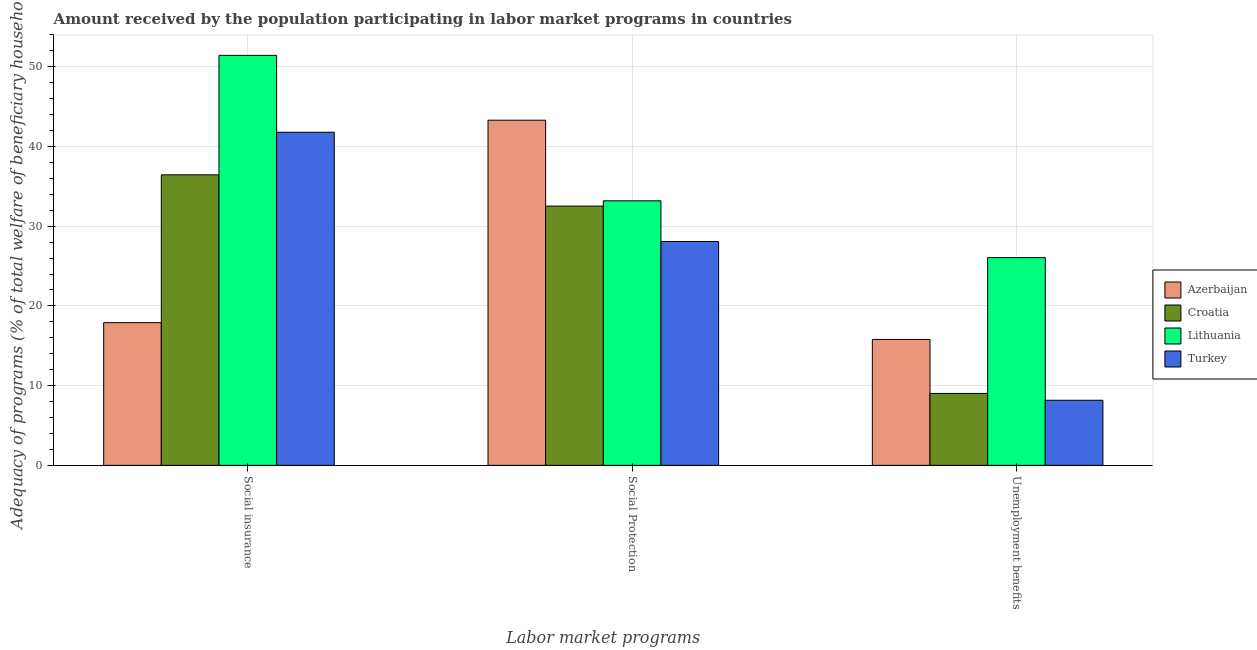How many different coloured bars are there?
Make the answer very short. 4. How many groups of bars are there?
Give a very brief answer. 3. Are the number of bars on each tick of the X-axis equal?
Offer a very short reply. Yes. What is the label of the 3rd group of bars from the left?
Give a very brief answer. Unemployment benefits. What is the amount received by the population participating in unemployment benefits programs in Croatia?
Give a very brief answer. 9.02. Across all countries, what is the maximum amount received by the population participating in unemployment benefits programs?
Your answer should be very brief. 26.06. Across all countries, what is the minimum amount received by the population participating in social insurance programs?
Offer a very short reply. 17.9. In which country was the amount received by the population participating in social insurance programs maximum?
Offer a terse response. Lithuania. What is the total amount received by the population participating in social protection programs in the graph?
Make the answer very short. 137.1. What is the difference between the amount received by the population participating in social protection programs in Lithuania and that in Turkey?
Provide a succinct answer. 5.1. What is the difference between the amount received by the population participating in social protection programs in Croatia and the amount received by the population participating in unemployment benefits programs in Azerbaijan?
Offer a terse response. 16.73. What is the average amount received by the population participating in unemployment benefits programs per country?
Your answer should be very brief. 14.76. What is the difference between the amount received by the population participating in social insurance programs and amount received by the population participating in unemployment benefits programs in Azerbaijan?
Offer a very short reply. 2.1. What is the ratio of the amount received by the population participating in social protection programs in Turkey to that in Azerbaijan?
Provide a short and direct response. 0.65. What is the difference between the highest and the second highest amount received by the population participating in unemployment benefits programs?
Keep it short and to the point. 10.26. What is the difference between the highest and the lowest amount received by the population participating in unemployment benefits programs?
Your response must be concise. 17.89. In how many countries, is the amount received by the population participating in social protection programs greater than the average amount received by the population participating in social protection programs taken over all countries?
Make the answer very short. 1. Is the sum of the amount received by the population participating in social protection programs in Azerbaijan and Turkey greater than the maximum amount received by the population participating in social insurance programs across all countries?
Give a very brief answer. Yes. What does the 2nd bar from the left in Social Protection represents?
Your answer should be very brief. Croatia. What does the 4th bar from the right in Unemployment benefits represents?
Ensure brevity in your answer.  Azerbaijan. Does the graph contain grids?
Ensure brevity in your answer.  Yes. Where does the legend appear in the graph?
Offer a very short reply. Center right. What is the title of the graph?
Offer a terse response. Amount received by the population participating in labor market programs in countries. What is the label or title of the X-axis?
Your answer should be compact. Labor market programs. What is the label or title of the Y-axis?
Your answer should be very brief. Adequacy of programs (% of total welfare of beneficiary households). What is the Adequacy of programs (% of total welfare of beneficiary households) of Azerbaijan in Social insurance?
Provide a succinct answer. 17.9. What is the Adequacy of programs (% of total welfare of beneficiary households) of Croatia in Social insurance?
Your answer should be very brief. 36.45. What is the Adequacy of programs (% of total welfare of beneficiary households) in Lithuania in Social insurance?
Provide a succinct answer. 51.43. What is the Adequacy of programs (% of total welfare of beneficiary households) of Turkey in Social insurance?
Ensure brevity in your answer.  41.79. What is the Adequacy of programs (% of total welfare of beneficiary households) in Azerbaijan in Social Protection?
Provide a short and direct response. 43.3. What is the Adequacy of programs (% of total welfare of beneficiary households) of Croatia in Social Protection?
Keep it short and to the point. 32.52. What is the Adequacy of programs (% of total welfare of beneficiary households) of Lithuania in Social Protection?
Your answer should be compact. 33.19. What is the Adequacy of programs (% of total welfare of beneficiary households) of Turkey in Social Protection?
Your answer should be very brief. 28.08. What is the Adequacy of programs (% of total welfare of beneficiary households) in Azerbaijan in Unemployment benefits?
Provide a succinct answer. 15.8. What is the Adequacy of programs (% of total welfare of beneficiary households) in Croatia in Unemployment benefits?
Give a very brief answer. 9.02. What is the Adequacy of programs (% of total welfare of beneficiary households) in Lithuania in Unemployment benefits?
Offer a terse response. 26.06. What is the Adequacy of programs (% of total welfare of beneficiary households) in Turkey in Unemployment benefits?
Keep it short and to the point. 8.17. Across all Labor market programs, what is the maximum Adequacy of programs (% of total welfare of beneficiary households) of Azerbaijan?
Your answer should be very brief. 43.3. Across all Labor market programs, what is the maximum Adequacy of programs (% of total welfare of beneficiary households) in Croatia?
Provide a succinct answer. 36.45. Across all Labor market programs, what is the maximum Adequacy of programs (% of total welfare of beneficiary households) in Lithuania?
Ensure brevity in your answer.  51.43. Across all Labor market programs, what is the maximum Adequacy of programs (% of total welfare of beneficiary households) of Turkey?
Offer a terse response. 41.79. Across all Labor market programs, what is the minimum Adequacy of programs (% of total welfare of beneficiary households) of Azerbaijan?
Keep it short and to the point. 15.8. Across all Labor market programs, what is the minimum Adequacy of programs (% of total welfare of beneficiary households) in Croatia?
Offer a terse response. 9.02. Across all Labor market programs, what is the minimum Adequacy of programs (% of total welfare of beneficiary households) of Lithuania?
Keep it short and to the point. 26.06. Across all Labor market programs, what is the minimum Adequacy of programs (% of total welfare of beneficiary households) of Turkey?
Make the answer very short. 8.17. What is the total Adequacy of programs (% of total welfare of beneficiary households) in Azerbaijan in the graph?
Keep it short and to the point. 76.99. What is the total Adequacy of programs (% of total welfare of beneficiary households) of Croatia in the graph?
Keep it short and to the point. 77.99. What is the total Adequacy of programs (% of total welfare of beneficiary households) in Lithuania in the graph?
Your answer should be compact. 110.68. What is the total Adequacy of programs (% of total welfare of beneficiary households) in Turkey in the graph?
Ensure brevity in your answer.  78.04. What is the difference between the Adequacy of programs (% of total welfare of beneficiary households) in Azerbaijan in Social insurance and that in Social Protection?
Your answer should be very brief. -25.4. What is the difference between the Adequacy of programs (% of total welfare of beneficiary households) in Croatia in Social insurance and that in Social Protection?
Ensure brevity in your answer.  3.92. What is the difference between the Adequacy of programs (% of total welfare of beneficiary households) in Lithuania in Social insurance and that in Social Protection?
Your response must be concise. 18.24. What is the difference between the Adequacy of programs (% of total welfare of beneficiary households) of Turkey in Social insurance and that in Social Protection?
Provide a succinct answer. 13.71. What is the difference between the Adequacy of programs (% of total welfare of beneficiary households) in Azerbaijan in Social insurance and that in Unemployment benefits?
Make the answer very short. 2.1. What is the difference between the Adequacy of programs (% of total welfare of beneficiary households) in Croatia in Social insurance and that in Unemployment benefits?
Your answer should be very brief. 27.43. What is the difference between the Adequacy of programs (% of total welfare of beneficiary households) of Lithuania in Social insurance and that in Unemployment benefits?
Your response must be concise. 25.37. What is the difference between the Adequacy of programs (% of total welfare of beneficiary households) in Turkey in Social insurance and that in Unemployment benefits?
Keep it short and to the point. 33.62. What is the difference between the Adequacy of programs (% of total welfare of beneficiary households) of Azerbaijan in Social Protection and that in Unemployment benefits?
Offer a very short reply. 27.5. What is the difference between the Adequacy of programs (% of total welfare of beneficiary households) of Croatia in Social Protection and that in Unemployment benefits?
Provide a succinct answer. 23.5. What is the difference between the Adequacy of programs (% of total welfare of beneficiary households) of Lithuania in Social Protection and that in Unemployment benefits?
Keep it short and to the point. 7.13. What is the difference between the Adequacy of programs (% of total welfare of beneficiary households) of Turkey in Social Protection and that in Unemployment benefits?
Offer a very short reply. 19.92. What is the difference between the Adequacy of programs (% of total welfare of beneficiary households) in Azerbaijan in Social insurance and the Adequacy of programs (% of total welfare of beneficiary households) in Croatia in Social Protection?
Provide a succinct answer. -14.62. What is the difference between the Adequacy of programs (% of total welfare of beneficiary households) in Azerbaijan in Social insurance and the Adequacy of programs (% of total welfare of beneficiary households) in Lithuania in Social Protection?
Provide a short and direct response. -15.29. What is the difference between the Adequacy of programs (% of total welfare of beneficiary households) in Azerbaijan in Social insurance and the Adequacy of programs (% of total welfare of beneficiary households) in Turkey in Social Protection?
Offer a very short reply. -10.18. What is the difference between the Adequacy of programs (% of total welfare of beneficiary households) in Croatia in Social insurance and the Adequacy of programs (% of total welfare of beneficiary households) in Lithuania in Social Protection?
Keep it short and to the point. 3.26. What is the difference between the Adequacy of programs (% of total welfare of beneficiary households) of Croatia in Social insurance and the Adequacy of programs (% of total welfare of beneficiary households) of Turkey in Social Protection?
Keep it short and to the point. 8.36. What is the difference between the Adequacy of programs (% of total welfare of beneficiary households) of Lithuania in Social insurance and the Adequacy of programs (% of total welfare of beneficiary households) of Turkey in Social Protection?
Give a very brief answer. 23.35. What is the difference between the Adequacy of programs (% of total welfare of beneficiary households) of Azerbaijan in Social insurance and the Adequacy of programs (% of total welfare of beneficiary households) of Croatia in Unemployment benefits?
Provide a succinct answer. 8.88. What is the difference between the Adequacy of programs (% of total welfare of beneficiary households) of Azerbaijan in Social insurance and the Adequacy of programs (% of total welfare of beneficiary households) of Lithuania in Unemployment benefits?
Offer a terse response. -8.16. What is the difference between the Adequacy of programs (% of total welfare of beneficiary households) of Azerbaijan in Social insurance and the Adequacy of programs (% of total welfare of beneficiary households) of Turkey in Unemployment benefits?
Your answer should be compact. 9.73. What is the difference between the Adequacy of programs (% of total welfare of beneficiary households) of Croatia in Social insurance and the Adequacy of programs (% of total welfare of beneficiary households) of Lithuania in Unemployment benefits?
Give a very brief answer. 10.39. What is the difference between the Adequacy of programs (% of total welfare of beneficiary households) of Croatia in Social insurance and the Adequacy of programs (% of total welfare of beneficiary households) of Turkey in Unemployment benefits?
Offer a terse response. 28.28. What is the difference between the Adequacy of programs (% of total welfare of beneficiary households) in Lithuania in Social insurance and the Adequacy of programs (% of total welfare of beneficiary households) in Turkey in Unemployment benefits?
Your response must be concise. 43.26. What is the difference between the Adequacy of programs (% of total welfare of beneficiary households) of Azerbaijan in Social Protection and the Adequacy of programs (% of total welfare of beneficiary households) of Croatia in Unemployment benefits?
Your answer should be very brief. 34.28. What is the difference between the Adequacy of programs (% of total welfare of beneficiary households) of Azerbaijan in Social Protection and the Adequacy of programs (% of total welfare of beneficiary households) of Lithuania in Unemployment benefits?
Your answer should be compact. 17.24. What is the difference between the Adequacy of programs (% of total welfare of beneficiary households) in Azerbaijan in Social Protection and the Adequacy of programs (% of total welfare of beneficiary households) in Turkey in Unemployment benefits?
Ensure brevity in your answer.  35.13. What is the difference between the Adequacy of programs (% of total welfare of beneficiary households) in Croatia in Social Protection and the Adequacy of programs (% of total welfare of beneficiary households) in Lithuania in Unemployment benefits?
Keep it short and to the point. 6.47. What is the difference between the Adequacy of programs (% of total welfare of beneficiary households) in Croatia in Social Protection and the Adequacy of programs (% of total welfare of beneficiary households) in Turkey in Unemployment benefits?
Make the answer very short. 24.36. What is the difference between the Adequacy of programs (% of total welfare of beneficiary households) in Lithuania in Social Protection and the Adequacy of programs (% of total welfare of beneficiary households) in Turkey in Unemployment benefits?
Your response must be concise. 25.02. What is the average Adequacy of programs (% of total welfare of beneficiary households) of Azerbaijan per Labor market programs?
Make the answer very short. 25.66. What is the average Adequacy of programs (% of total welfare of beneficiary households) of Croatia per Labor market programs?
Ensure brevity in your answer.  26. What is the average Adequacy of programs (% of total welfare of beneficiary households) in Lithuania per Labor market programs?
Your response must be concise. 36.89. What is the average Adequacy of programs (% of total welfare of beneficiary households) in Turkey per Labor market programs?
Make the answer very short. 26.01. What is the difference between the Adequacy of programs (% of total welfare of beneficiary households) in Azerbaijan and Adequacy of programs (% of total welfare of beneficiary households) in Croatia in Social insurance?
Ensure brevity in your answer.  -18.55. What is the difference between the Adequacy of programs (% of total welfare of beneficiary households) in Azerbaijan and Adequacy of programs (% of total welfare of beneficiary households) in Lithuania in Social insurance?
Make the answer very short. -33.53. What is the difference between the Adequacy of programs (% of total welfare of beneficiary households) of Azerbaijan and Adequacy of programs (% of total welfare of beneficiary households) of Turkey in Social insurance?
Give a very brief answer. -23.89. What is the difference between the Adequacy of programs (% of total welfare of beneficiary households) in Croatia and Adequacy of programs (% of total welfare of beneficiary households) in Lithuania in Social insurance?
Your response must be concise. -14.98. What is the difference between the Adequacy of programs (% of total welfare of beneficiary households) of Croatia and Adequacy of programs (% of total welfare of beneficiary households) of Turkey in Social insurance?
Offer a terse response. -5.34. What is the difference between the Adequacy of programs (% of total welfare of beneficiary households) in Lithuania and Adequacy of programs (% of total welfare of beneficiary households) in Turkey in Social insurance?
Ensure brevity in your answer.  9.64. What is the difference between the Adequacy of programs (% of total welfare of beneficiary households) of Azerbaijan and Adequacy of programs (% of total welfare of beneficiary households) of Croatia in Social Protection?
Offer a very short reply. 10.78. What is the difference between the Adequacy of programs (% of total welfare of beneficiary households) of Azerbaijan and Adequacy of programs (% of total welfare of beneficiary households) of Lithuania in Social Protection?
Keep it short and to the point. 10.11. What is the difference between the Adequacy of programs (% of total welfare of beneficiary households) of Azerbaijan and Adequacy of programs (% of total welfare of beneficiary households) of Turkey in Social Protection?
Make the answer very short. 15.22. What is the difference between the Adequacy of programs (% of total welfare of beneficiary households) of Croatia and Adequacy of programs (% of total welfare of beneficiary households) of Lithuania in Social Protection?
Provide a succinct answer. -0.66. What is the difference between the Adequacy of programs (% of total welfare of beneficiary households) in Croatia and Adequacy of programs (% of total welfare of beneficiary households) in Turkey in Social Protection?
Provide a succinct answer. 4.44. What is the difference between the Adequacy of programs (% of total welfare of beneficiary households) of Lithuania and Adequacy of programs (% of total welfare of beneficiary households) of Turkey in Social Protection?
Keep it short and to the point. 5.1. What is the difference between the Adequacy of programs (% of total welfare of beneficiary households) in Azerbaijan and Adequacy of programs (% of total welfare of beneficiary households) in Croatia in Unemployment benefits?
Provide a succinct answer. 6.77. What is the difference between the Adequacy of programs (% of total welfare of beneficiary households) of Azerbaijan and Adequacy of programs (% of total welfare of beneficiary households) of Lithuania in Unemployment benefits?
Your answer should be compact. -10.26. What is the difference between the Adequacy of programs (% of total welfare of beneficiary households) in Azerbaijan and Adequacy of programs (% of total welfare of beneficiary households) in Turkey in Unemployment benefits?
Make the answer very short. 7.63. What is the difference between the Adequacy of programs (% of total welfare of beneficiary households) in Croatia and Adequacy of programs (% of total welfare of beneficiary households) in Lithuania in Unemployment benefits?
Keep it short and to the point. -17.04. What is the difference between the Adequacy of programs (% of total welfare of beneficiary households) in Croatia and Adequacy of programs (% of total welfare of beneficiary households) in Turkey in Unemployment benefits?
Your response must be concise. 0.85. What is the difference between the Adequacy of programs (% of total welfare of beneficiary households) in Lithuania and Adequacy of programs (% of total welfare of beneficiary households) in Turkey in Unemployment benefits?
Provide a short and direct response. 17.89. What is the ratio of the Adequacy of programs (% of total welfare of beneficiary households) of Azerbaijan in Social insurance to that in Social Protection?
Give a very brief answer. 0.41. What is the ratio of the Adequacy of programs (% of total welfare of beneficiary households) of Croatia in Social insurance to that in Social Protection?
Keep it short and to the point. 1.12. What is the ratio of the Adequacy of programs (% of total welfare of beneficiary households) in Lithuania in Social insurance to that in Social Protection?
Give a very brief answer. 1.55. What is the ratio of the Adequacy of programs (% of total welfare of beneficiary households) of Turkey in Social insurance to that in Social Protection?
Your answer should be very brief. 1.49. What is the ratio of the Adequacy of programs (% of total welfare of beneficiary households) in Azerbaijan in Social insurance to that in Unemployment benefits?
Keep it short and to the point. 1.13. What is the ratio of the Adequacy of programs (% of total welfare of beneficiary households) of Croatia in Social insurance to that in Unemployment benefits?
Offer a terse response. 4.04. What is the ratio of the Adequacy of programs (% of total welfare of beneficiary households) in Lithuania in Social insurance to that in Unemployment benefits?
Your answer should be compact. 1.97. What is the ratio of the Adequacy of programs (% of total welfare of beneficiary households) of Turkey in Social insurance to that in Unemployment benefits?
Make the answer very short. 5.12. What is the ratio of the Adequacy of programs (% of total welfare of beneficiary households) of Azerbaijan in Social Protection to that in Unemployment benefits?
Offer a terse response. 2.74. What is the ratio of the Adequacy of programs (% of total welfare of beneficiary households) of Croatia in Social Protection to that in Unemployment benefits?
Provide a succinct answer. 3.61. What is the ratio of the Adequacy of programs (% of total welfare of beneficiary households) of Lithuania in Social Protection to that in Unemployment benefits?
Offer a terse response. 1.27. What is the ratio of the Adequacy of programs (% of total welfare of beneficiary households) in Turkey in Social Protection to that in Unemployment benefits?
Keep it short and to the point. 3.44. What is the difference between the highest and the second highest Adequacy of programs (% of total welfare of beneficiary households) in Azerbaijan?
Offer a terse response. 25.4. What is the difference between the highest and the second highest Adequacy of programs (% of total welfare of beneficiary households) in Croatia?
Provide a short and direct response. 3.92. What is the difference between the highest and the second highest Adequacy of programs (% of total welfare of beneficiary households) in Lithuania?
Provide a short and direct response. 18.24. What is the difference between the highest and the second highest Adequacy of programs (% of total welfare of beneficiary households) of Turkey?
Ensure brevity in your answer.  13.71. What is the difference between the highest and the lowest Adequacy of programs (% of total welfare of beneficiary households) in Azerbaijan?
Ensure brevity in your answer.  27.5. What is the difference between the highest and the lowest Adequacy of programs (% of total welfare of beneficiary households) of Croatia?
Give a very brief answer. 27.43. What is the difference between the highest and the lowest Adequacy of programs (% of total welfare of beneficiary households) in Lithuania?
Make the answer very short. 25.37. What is the difference between the highest and the lowest Adequacy of programs (% of total welfare of beneficiary households) of Turkey?
Your response must be concise. 33.62. 